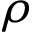Convert formula to latex. <formula><loc_0><loc_0><loc_500><loc_500>\rho</formula> 